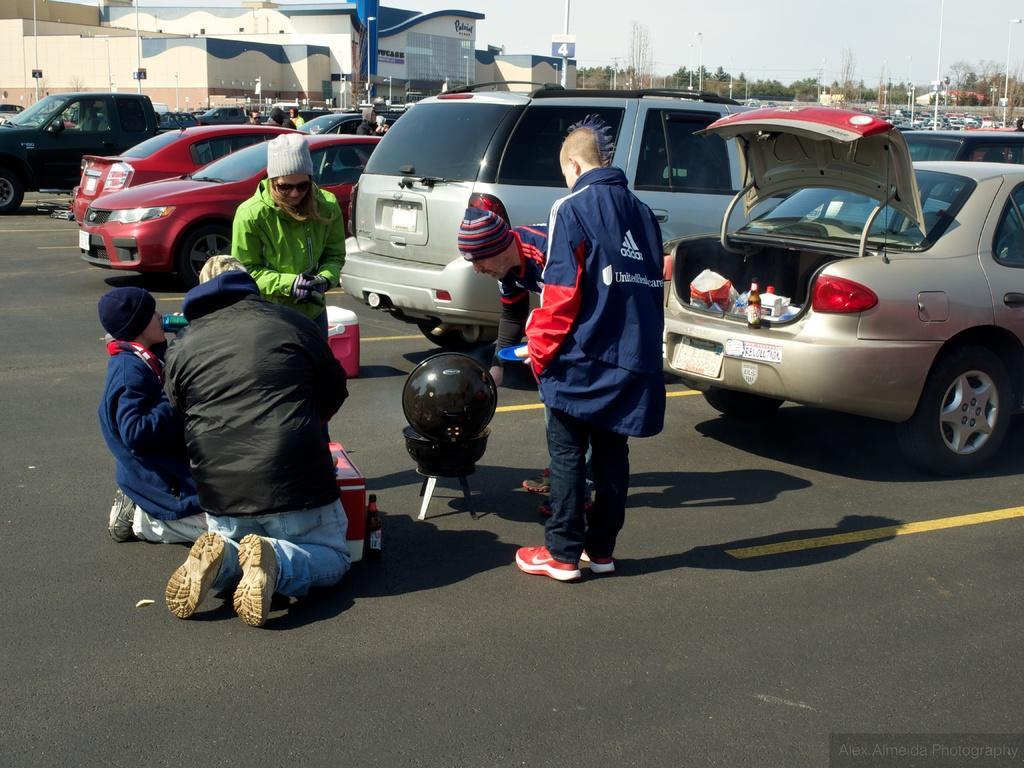How would you summarize this image in a sentence or two? In this image we can see people. In the center there is a charcoal grill. At the bottom there is a road and we can see vehicles on the road. In the background there are trees, buildings, poles and sky. 